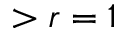Convert formula to latex. <formula><loc_0><loc_0><loc_500><loc_500>> r = 1</formula> 